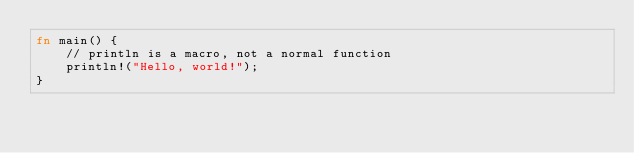<code> <loc_0><loc_0><loc_500><loc_500><_Rust_>fn main() {
    // println is a macro, not a normal function
    println!("Hello, world!");
}
</code> 